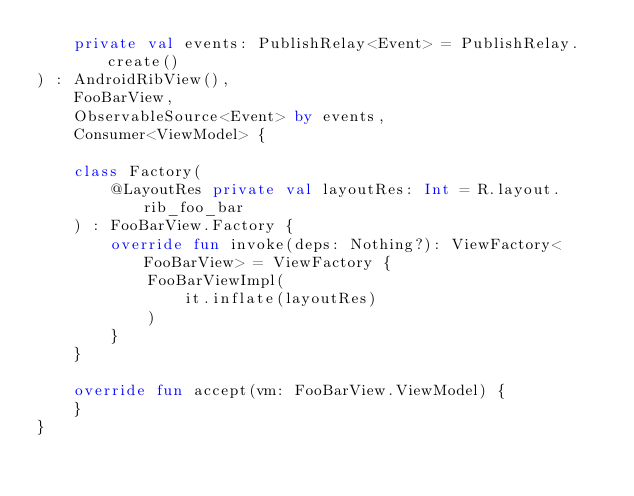<code> <loc_0><loc_0><loc_500><loc_500><_Kotlin_>    private val events: PublishRelay<Event> = PublishRelay.create()
) : AndroidRibView(),
    FooBarView,
    ObservableSource<Event> by events,
    Consumer<ViewModel> {

    class Factory(
        @LayoutRes private val layoutRes: Int = R.layout.rib_foo_bar
    ) : FooBarView.Factory {
        override fun invoke(deps: Nothing?): ViewFactory<FooBarView> = ViewFactory {
            FooBarViewImpl(
                it.inflate(layoutRes)
            )
        }
    }

    override fun accept(vm: FooBarView.ViewModel) {
    }
}
</code> 